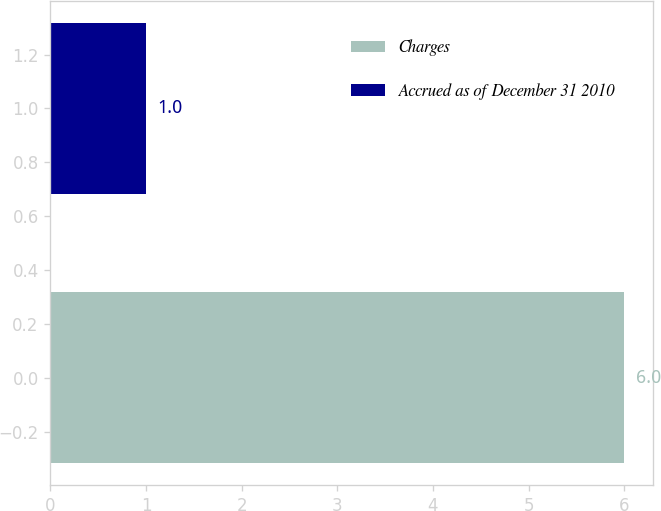<chart> <loc_0><loc_0><loc_500><loc_500><bar_chart><fcel>Charges<fcel>Accrued as of December 31 2010<nl><fcel>6<fcel>1<nl></chart> 